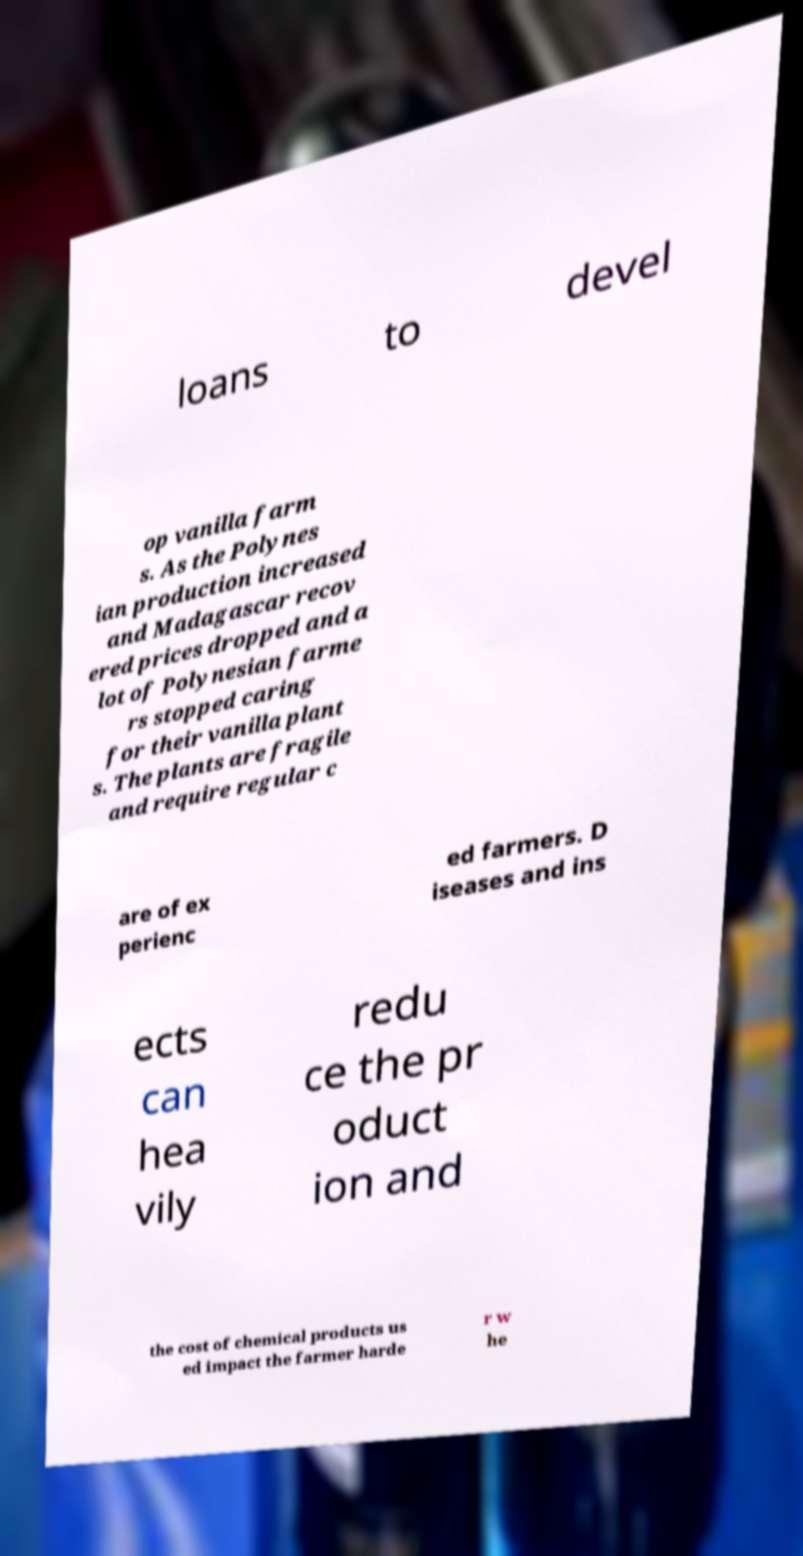Could you assist in decoding the text presented in this image and type it out clearly? loans to devel op vanilla farm s. As the Polynes ian production increased and Madagascar recov ered prices dropped and a lot of Polynesian farme rs stopped caring for their vanilla plant s. The plants are fragile and require regular c are of ex perienc ed farmers. D iseases and ins ects can hea vily redu ce the pr oduct ion and the cost of chemical products us ed impact the farmer harde r w he 